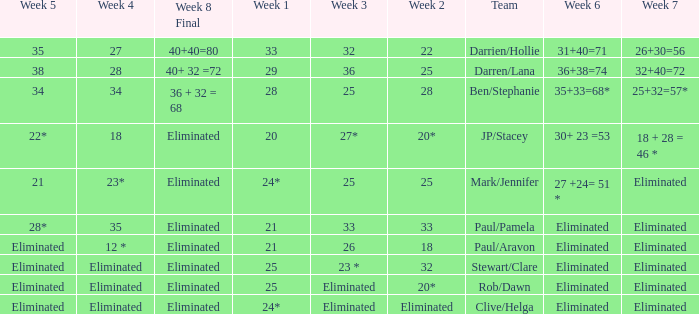Name the week 6 when week 3 is 25 and week 7 is eliminated 27 +24= 51 *. 